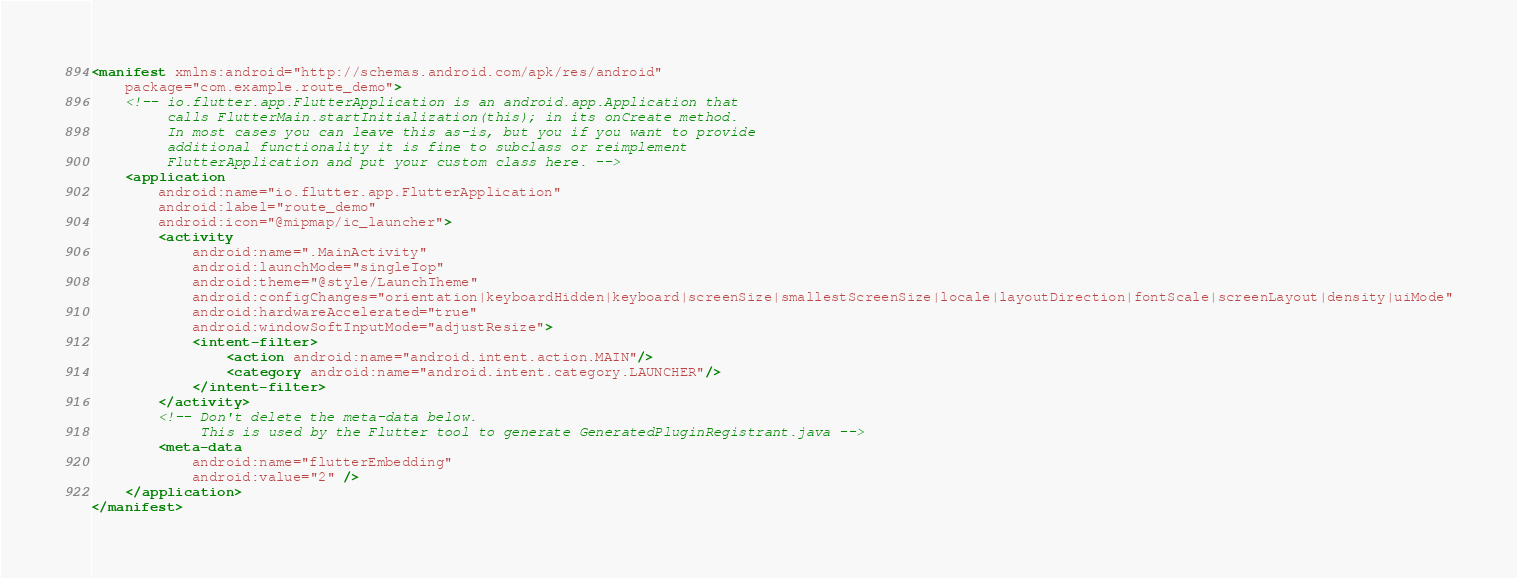<code> <loc_0><loc_0><loc_500><loc_500><_XML_><manifest xmlns:android="http://schemas.android.com/apk/res/android"
    package="com.example.route_demo">
    <!-- io.flutter.app.FlutterApplication is an android.app.Application that
         calls FlutterMain.startInitialization(this); in its onCreate method.
         In most cases you can leave this as-is, but you if you want to provide
         additional functionality it is fine to subclass or reimplement
         FlutterApplication and put your custom class here. -->
    <application
        android:name="io.flutter.app.FlutterApplication"
        android:label="route_demo"
        android:icon="@mipmap/ic_launcher">
        <activity
            android:name=".MainActivity"
            android:launchMode="singleTop"
            android:theme="@style/LaunchTheme"
            android:configChanges="orientation|keyboardHidden|keyboard|screenSize|smallestScreenSize|locale|layoutDirection|fontScale|screenLayout|density|uiMode"
            android:hardwareAccelerated="true"
            android:windowSoftInputMode="adjustResize">
            <intent-filter>
                <action android:name="android.intent.action.MAIN"/>
                <category android:name="android.intent.category.LAUNCHER"/>
            </intent-filter>
        </activity>
        <!-- Don't delete the meta-data below.
             This is used by the Flutter tool to generate GeneratedPluginRegistrant.java -->
        <meta-data
            android:name="flutterEmbedding"
            android:value="2" />
    </application>
</manifest>
</code> 